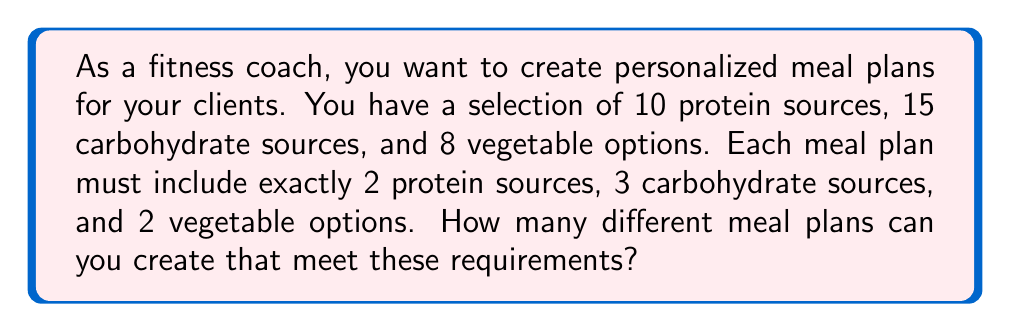What is the answer to this math problem? To solve this problem, we'll use the multiplication principle of counting. We need to calculate the number of ways to choose each component of the meal plan and then multiply these together.

1. Choosing protein sources:
   We need to select 2 protein sources from 10 options. This is a combination problem, denoted as $\binom{10}{2}$.
   $$\binom{10}{2} = \frac{10!}{2!(10-2)!} = \frac{10!}{2!8!} = 45$$

2. Choosing carbohydrate sources:
   We need to select 3 carbohydrate sources from 15 options. This is denoted as $\binom{15}{3}$.
   $$\binom{15}{3} = \frac{15!}{3!(15-3)!} = \frac{15!}{3!12!} = 455$$

3. Choosing vegetable options:
   We need to select 2 vegetable options from 8 choices. This is denoted as $\binom{8}{2}$.
   $$\binom{8}{2} = \frac{8!}{2!(8-2)!} = \frac{8!}{2!6!} = 28$$

Now, we apply the multiplication principle. The total number of possible meal plans is the product of these three combinations:

$$45 \times 455 \times 28 = 573,300$$

This calculation gives us the total number of unique meal plans that can be created while meeting the specified requirements.
Answer: 573,300 different meal plans 